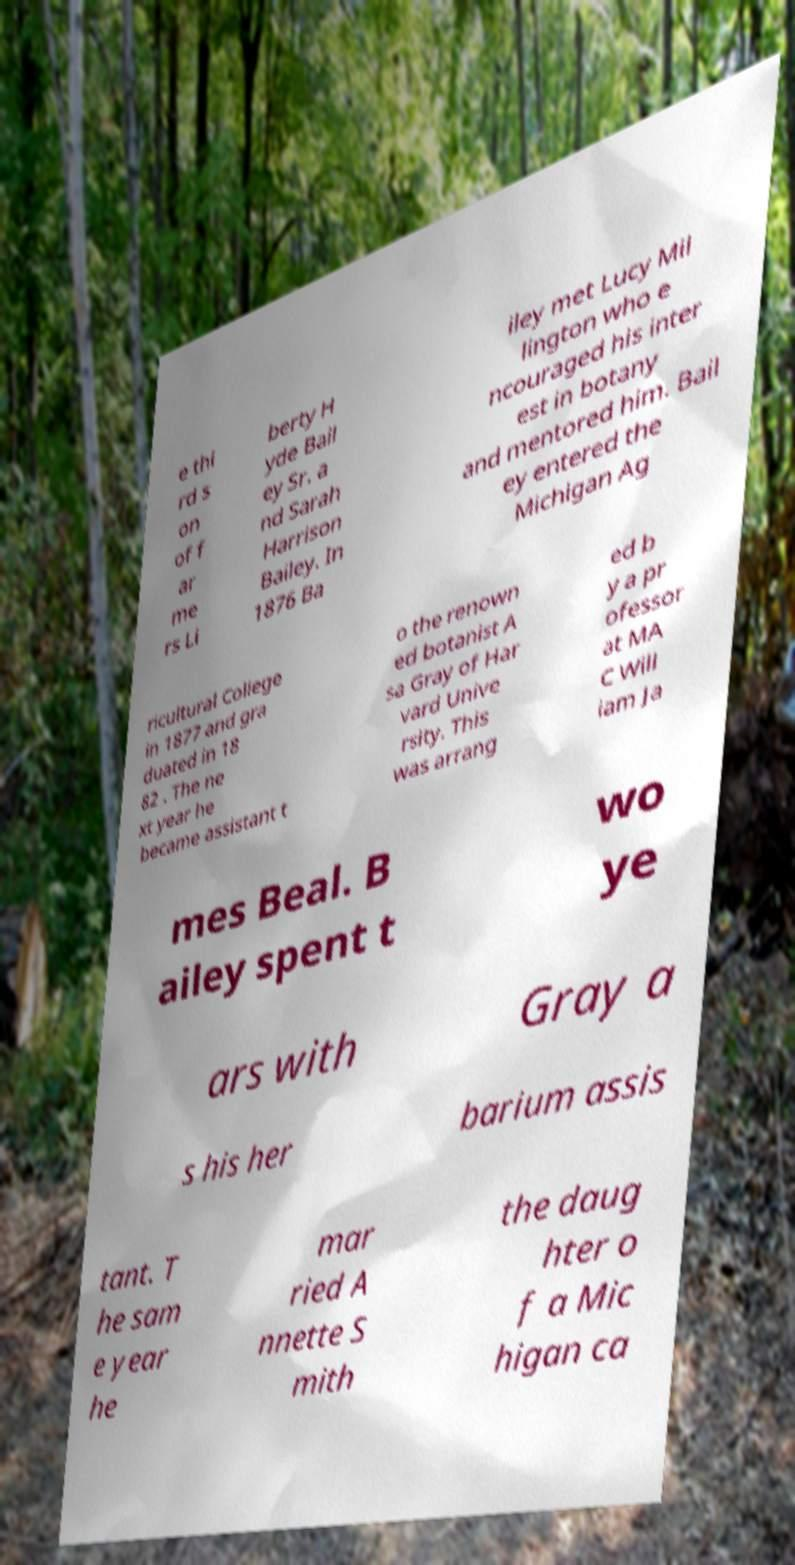Please identify and transcribe the text found in this image. e thi rd s on of f ar me rs Li berty H yde Bail ey Sr. a nd Sarah Harrison Bailey. In 1876 Ba iley met Lucy Mil lington who e ncouraged his inter est in botany and mentored him. Bail ey entered the Michigan Ag ricultural College in 1877 and gra duated in 18 82 . The ne xt year he became assistant t o the renown ed botanist A sa Gray of Har vard Unive rsity. This was arrang ed b y a pr ofessor at MA C Will iam Ja mes Beal. B ailey spent t wo ye ars with Gray a s his her barium assis tant. T he sam e year he mar ried A nnette S mith the daug hter o f a Mic higan ca 